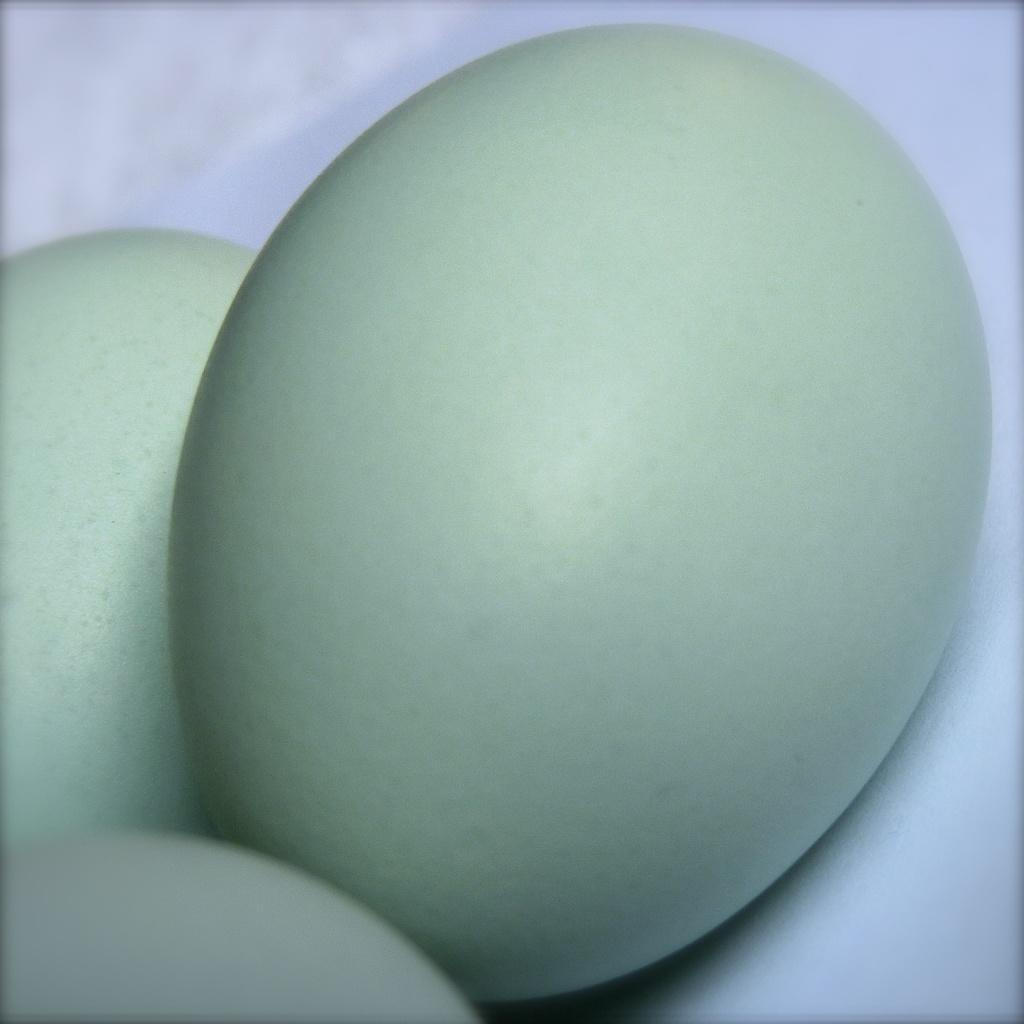Can you describe this image briefly? In the middle of the image there are three eggs on the white surface. 